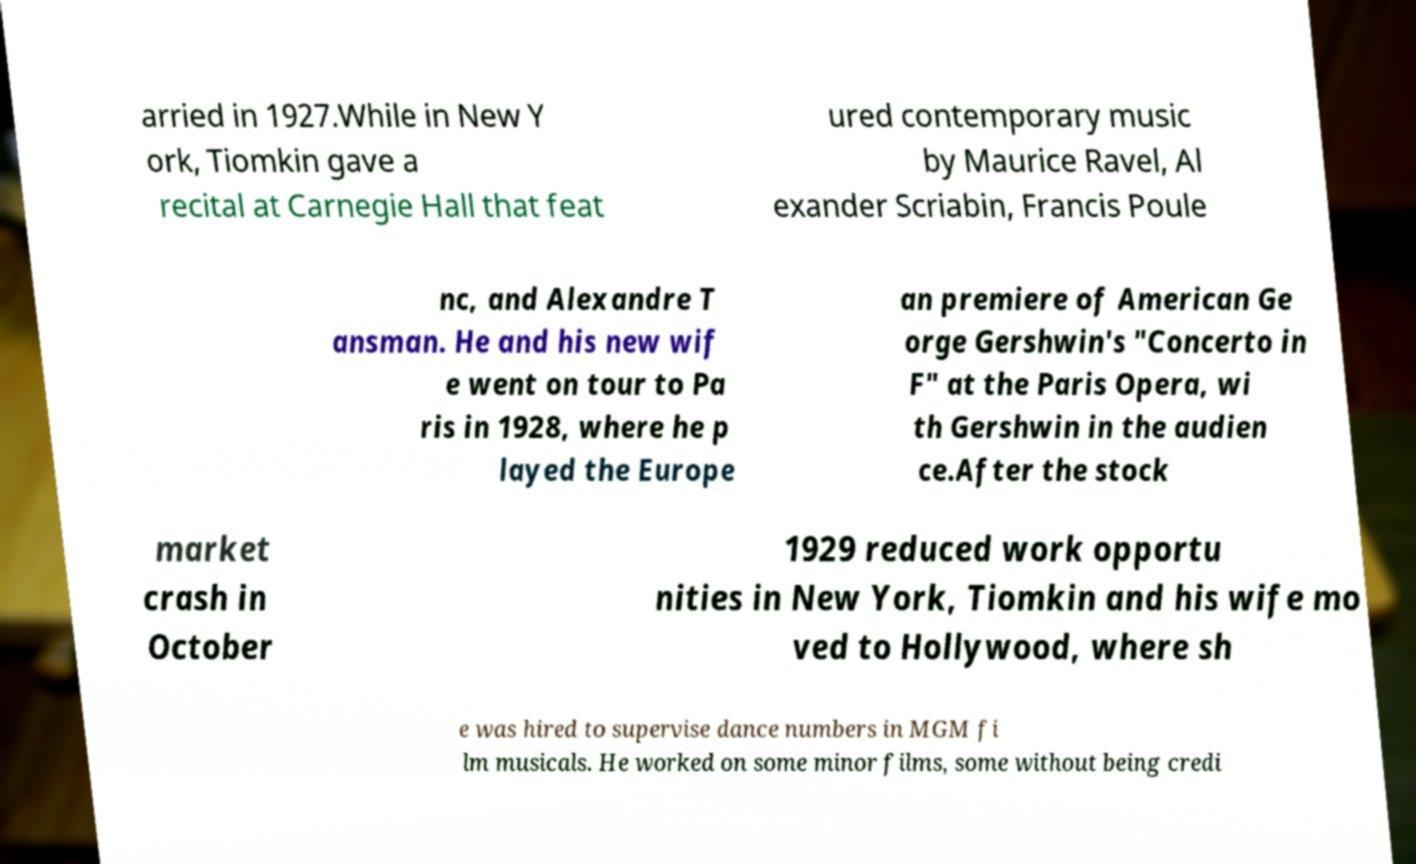Can you accurately transcribe the text from the provided image for me? arried in 1927.While in New Y ork, Tiomkin gave a recital at Carnegie Hall that feat ured contemporary music by Maurice Ravel, Al exander Scriabin, Francis Poule nc, and Alexandre T ansman. He and his new wif e went on tour to Pa ris in 1928, where he p layed the Europe an premiere of American Ge orge Gershwin's "Concerto in F" at the Paris Opera, wi th Gershwin in the audien ce.After the stock market crash in October 1929 reduced work opportu nities in New York, Tiomkin and his wife mo ved to Hollywood, where sh e was hired to supervise dance numbers in MGM fi lm musicals. He worked on some minor films, some without being credi 